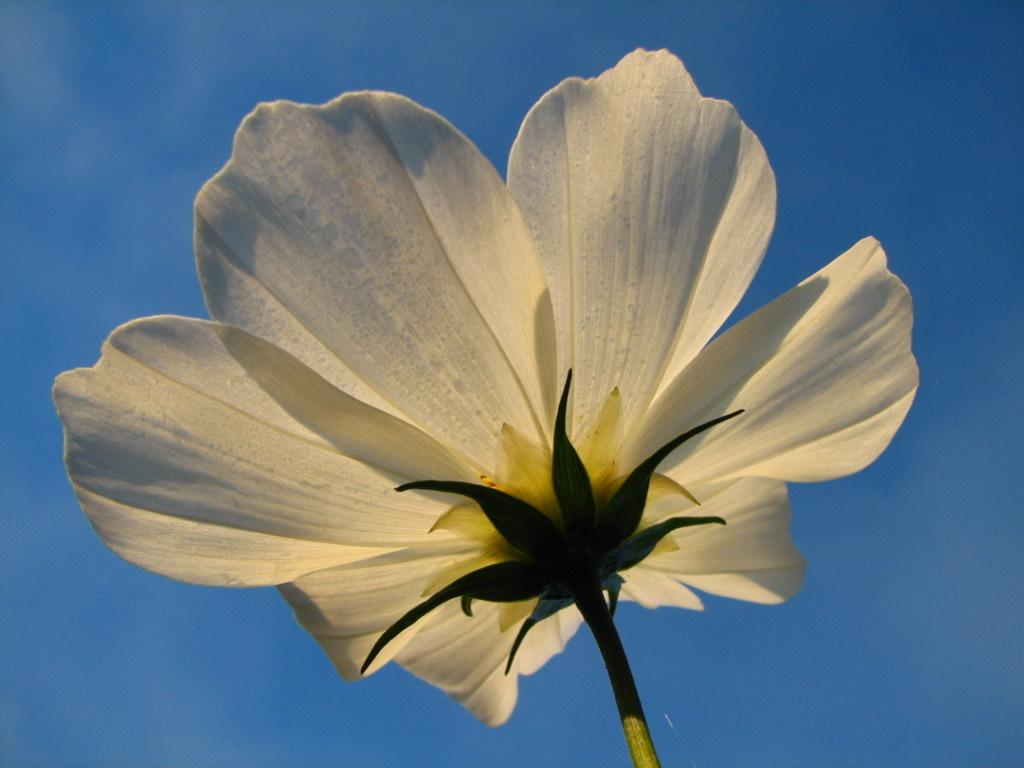What is the main subject of the image? There is a flower in the image. What can be seen in the background of the image? The sky is visible in the image. What grade did the flower receive on its recent operation? There is no mention of an operation or grade in the image, as it only features a flower and the sky. 